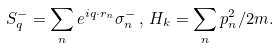<formula> <loc_0><loc_0><loc_500><loc_500>S ^ { - } _ { q } = \sum _ { n } e ^ { i { q } \cdot { r } _ { n } } \sigma ^ { - } _ { n } \, , \, H _ { k } = \sum _ { n } { p } ^ { 2 } _ { n } / 2 m .</formula> 